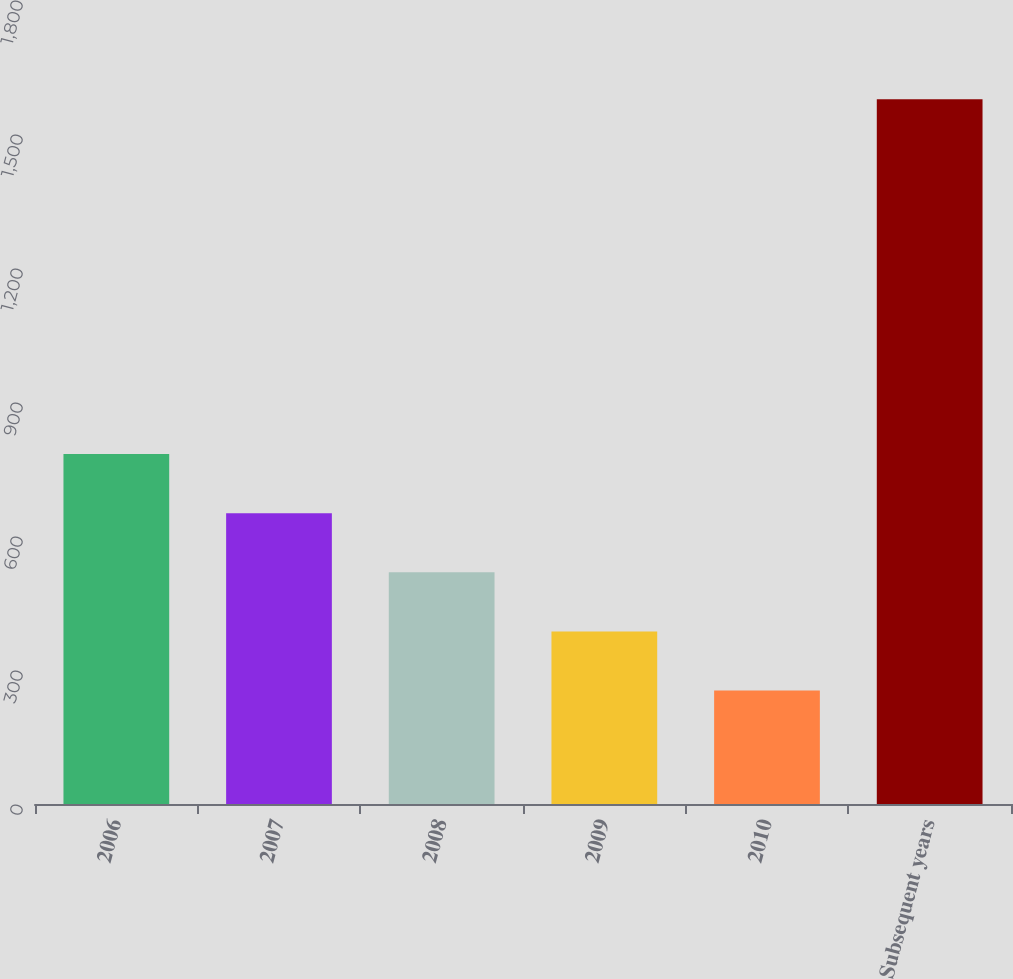<chart> <loc_0><loc_0><loc_500><loc_500><bar_chart><fcel>2006<fcel>2007<fcel>2008<fcel>2009<fcel>2010<fcel>Subsequent years<nl><fcel>783.6<fcel>651.2<fcel>518.8<fcel>386.4<fcel>254<fcel>1578<nl></chart> 